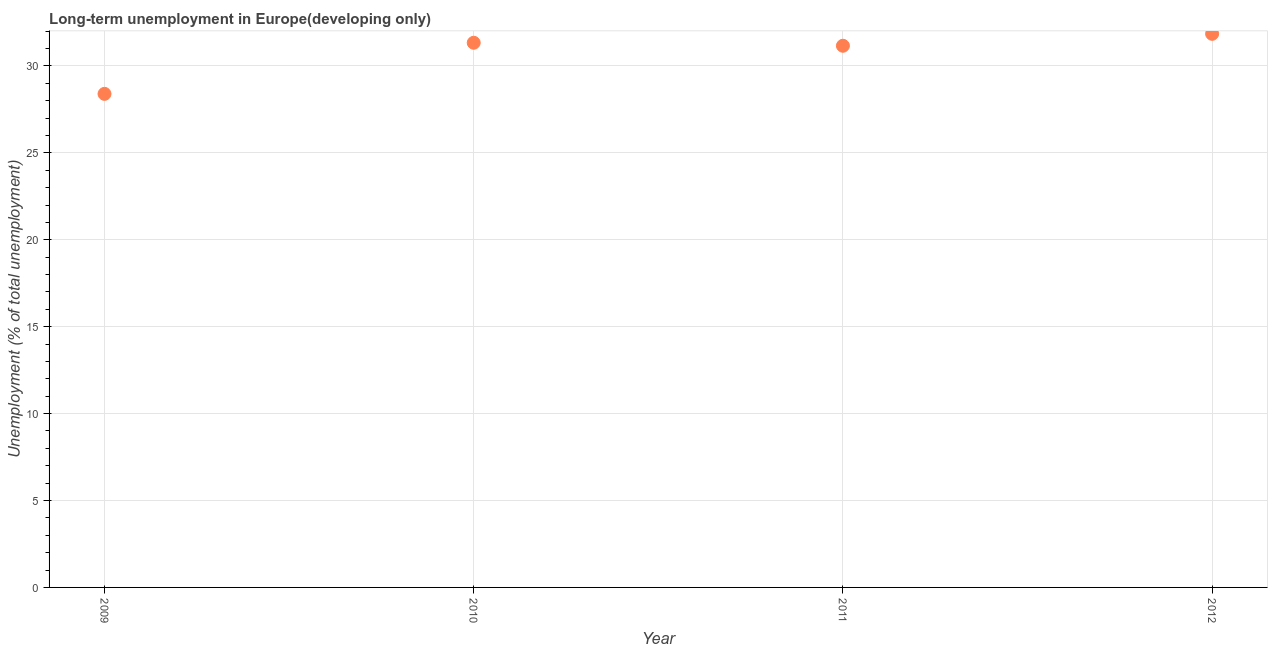What is the long-term unemployment in 2012?
Offer a terse response. 31.85. Across all years, what is the maximum long-term unemployment?
Offer a terse response. 31.85. Across all years, what is the minimum long-term unemployment?
Keep it short and to the point. 28.4. In which year was the long-term unemployment minimum?
Provide a short and direct response. 2009. What is the sum of the long-term unemployment?
Your answer should be compact. 122.74. What is the difference between the long-term unemployment in 2010 and 2012?
Give a very brief answer. -0.51. What is the average long-term unemployment per year?
Your answer should be very brief. 30.69. What is the median long-term unemployment?
Your answer should be very brief. 31.25. What is the ratio of the long-term unemployment in 2009 to that in 2010?
Provide a short and direct response. 0.91. Is the long-term unemployment in 2011 less than that in 2012?
Offer a terse response. Yes. What is the difference between the highest and the second highest long-term unemployment?
Your response must be concise. 0.51. Is the sum of the long-term unemployment in 2010 and 2011 greater than the maximum long-term unemployment across all years?
Your answer should be compact. Yes. What is the difference between the highest and the lowest long-term unemployment?
Provide a short and direct response. 3.45. Does the long-term unemployment monotonically increase over the years?
Offer a very short reply. No. What is the difference between two consecutive major ticks on the Y-axis?
Your answer should be compact. 5. Are the values on the major ticks of Y-axis written in scientific E-notation?
Your answer should be very brief. No. Does the graph contain grids?
Your answer should be very brief. Yes. What is the title of the graph?
Your answer should be compact. Long-term unemployment in Europe(developing only). What is the label or title of the Y-axis?
Offer a very short reply. Unemployment (% of total unemployment). What is the Unemployment (% of total unemployment) in 2009?
Make the answer very short. 28.4. What is the Unemployment (% of total unemployment) in 2010?
Provide a succinct answer. 31.34. What is the Unemployment (% of total unemployment) in 2011?
Make the answer very short. 31.16. What is the Unemployment (% of total unemployment) in 2012?
Make the answer very short. 31.85. What is the difference between the Unemployment (% of total unemployment) in 2009 and 2010?
Make the answer very short. -2.94. What is the difference between the Unemployment (% of total unemployment) in 2009 and 2011?
Ensure brevity in your answer.  -2.77. What is the difference between the Unemployment (% of total unemployment) in 2009 and 2012?
Offer a terse response. -3.45. What is the difference between the Unemployment (% of total unemployment) in 2010 and 2011?
Provide a succinct answer. 0.17. What is the difference between the Unemployment (% of total unemployment) in 2010 and 2012?
Your response must be concise. -0.51. What is the difference between the Unemployment (% of total unemployment) in 2011 and 2012?
Your response must be concise. -0.69. What is the ratio of the Unemployment (% of total unemployment) in 2009 to that in 2010?
Make the answer very short. 0.91. What is the ratio of the Unemployment (% of total unemployment) in 2009 to that in 2011?
Your answer should be compact. 0.91. What is the ratio of the Unemployment (% of total unemployment) in 2009 to that in 2012?
Your answer should be compact. 0.89. What is the ratio of the Unemployment (% of total unemployment) in 2010 to that in 2011?
Keep it short and to the point. 1.01. What is the ratio of the Unemployment (% of total unemployment) in 2011 to that in 2012?
Your answer should be compact. 0.98. 